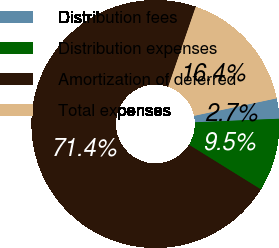Convert chart to OTSL. <chart><loc_0><loc_0><loc_500><loc_500><pie_chart><fcel>Distribution fees<fcel>Distribution expenses<fcel>Amortization of deferred<fcel>Total expenses<nl><fcel>2.65%<fcel>9.52%<fcel>71.43%<fcel>16.4%<nl></chart> 